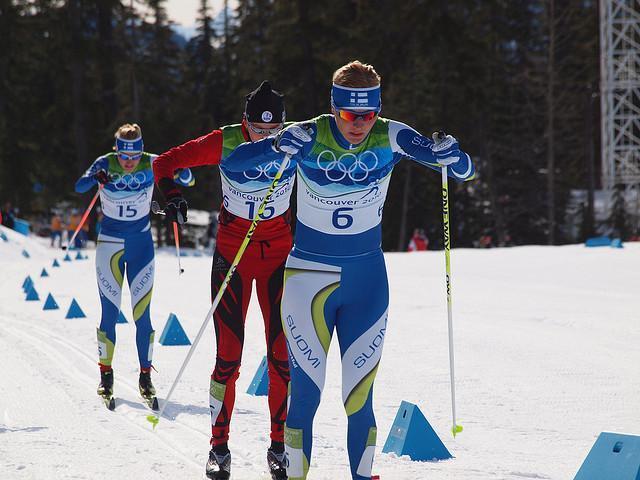How many red skiers do you see?
Give a very brief answer. 1. How many people with blue shirts?
Give a very brief answer. 2. How many people are there?
Give a very brief answer. 3. 